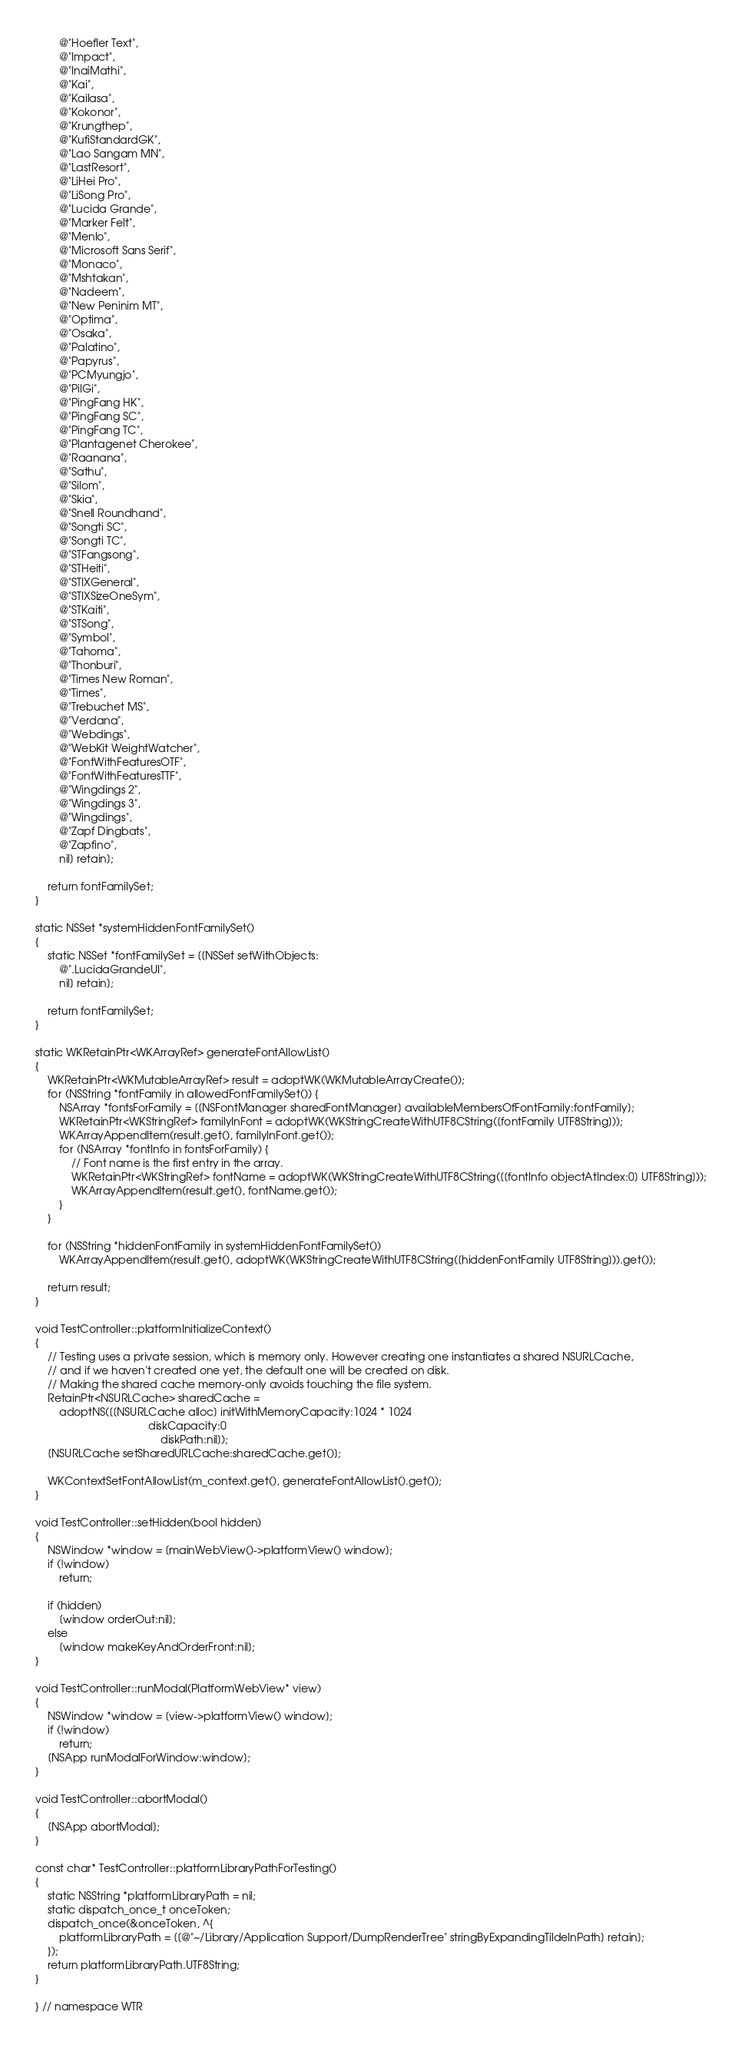<code> <loc_0><loc_0><loc_500><loc_500><_ObjectiveC_>        @"Hoefler Text",
        @"Impact",
        @"InaiMathi",
        @"Kai",
        @"Kailasa",
        @"Kokonor",
        @"Krungthep",
        @"KufiStandardGK",
        @"Lao Sangam MN",
        @"LastResort",
        @"LiHei Pro",
        @"LiSong Pro",
        @"Lucida Grande",
        @"Marker Felt",
        @"Menlo",
        @"Microsoft Sans Serif",
        @"Monaco",
        @"Mshtakan",
        @"Nadeem",
        @"New Peninim MT",
        @"Optima",
        @"Osaka",
        @"Palatino",
        @"Papyrus",
        @"PCMyungjo",
        @"PilGi",
        @"PingFang HK",
        @"PingFang SC",
        @"PingFang TC",
        @"Plantagenet Cherokee",
        @"Raanana",
        @"Sathu",
        @"Silom",
        @"Skia",
        @"Snell Roundhand",
        @"Songti SC",
        @"Songti TC",
        @"STFangsong",
        @"STHeiti",
        @"STIXGeneral",
        @"STIXSizeOneSym",
        @"STKaiti",
        @"STSong",
        @"Symbol",
        @"Tahoma",
        @"Thonburi",
        @"Times New Roman",
        @"Times",
        @"Trebuchet MS",
        @"Verdana",
        @"Webdings",
        @"WebKit WeightWatcher",
        @"FontWithFeaturesOTF",
        @"FontWithFeaturesTTF",
        @"Wingdings 2",
        @"Wingdings 3",
        @"Wingdings",
        @"Zapf Dingbats",
        @"Zapfino",
        nil] retain];

    return fontFamilySet;
}

static NSSet *systemHiddenFontFamilySet()
{
    static NSSet *fontFamilySet = [[NSSet setWithObjects:
        @".LucidaGrandeUI",
        nil] retain];

    return fontFamilySet;
}

static WKRetainPtr<WKArrayRef> generateFontAllowList()
{
    WKRetainPtr<WKMutableArrayRef> result = adoptWK(WKMutableArrayCreate());
    for (NSString *fontFamily in allowedFontFamilySet()) {
        NSArray *fontsForFamily = [[NSFontManager sharedFontManager] availableMembersOfFontFamily:fontFamily];
        WKRetainPtr<WKStringRef> familyInFont = adoptWK(WKStringCreateWithUTF8CString([fontFamily UTF8String]));
        WKArrayAppendItem(result.get(), familyInFont.get());
        for (NSArray *fontInfo in fontsForFamily) {
            // Font name is the first entry in the array.
            WKRetainPtr<WKStringRef> fontName = adoptWK(WKStringCreateWithUTF8CString([[fontInfo objectAtIndex:0] UTF8String]));
            WKArrayAppendItem(result.get(), fontName.get());
        }
    }

    for (NSString *hiddenFontFamily in systemHiddenFontFamilySet())
        WKArrayAppendItem(result.get(), adoptWK(WKStringCreateWithUTF8CString([hiddenFontFamily UTF8String])).get());

    return result;
}

void TestController::platformInitializeContext()
{
    // Testing uses a private session, which is memory only. However creating one instantiates a shared NSURLCache,
    // and if we haven't created one yet, the default one will be created on disk.
    // Making the shared cache memory-only avoids touching the file system.
    RetainPtr<NSURLCache> sharedCache =
        adoptNS([[NSURLCache alloc] initWithMemoryCapacity:1024 * 1024
                                      diskCapacity:0
                                          diskPath:nil]);
    [NSURLCache setSharedURLCache:sharedCache.get()];

    WKContextSetFontAllowList(m_context.get(), generateFontAllowList().get());
}

void TestController::setHidden(bool hidden)
{
    NSWindow *window = [mainWebView()->platformView() window];
    if (!window)
        return;

    if (hidden)
        [window orderOut:nil];
    else
        [window makeKeyAndOrderFront:nil];
}

void TestController::runModal(PlatformWebView* view)
{
    NSWindow *window = [view->platformView() window];
    if (!window)
        return;
    [NSApp runModalForWindow:window];
}

void TestController::abortModal()
{
    [NSApp abortModal];
}

const char* TestController::platformLibraryPathForTesting()
{
    static NSString *platformLibraryPath = nil;
    static dispatch_once_t onceToken;
    dispatch_once(&onceToken, ^{
        platformLibraryPath = [[@"~/Library/Application Support/DumpRenderTree" stringByExpandingTildeInPath] retain];
    });
    return platformLibraryPath.UTF8String;
}

} // namespace WTR
</code> 